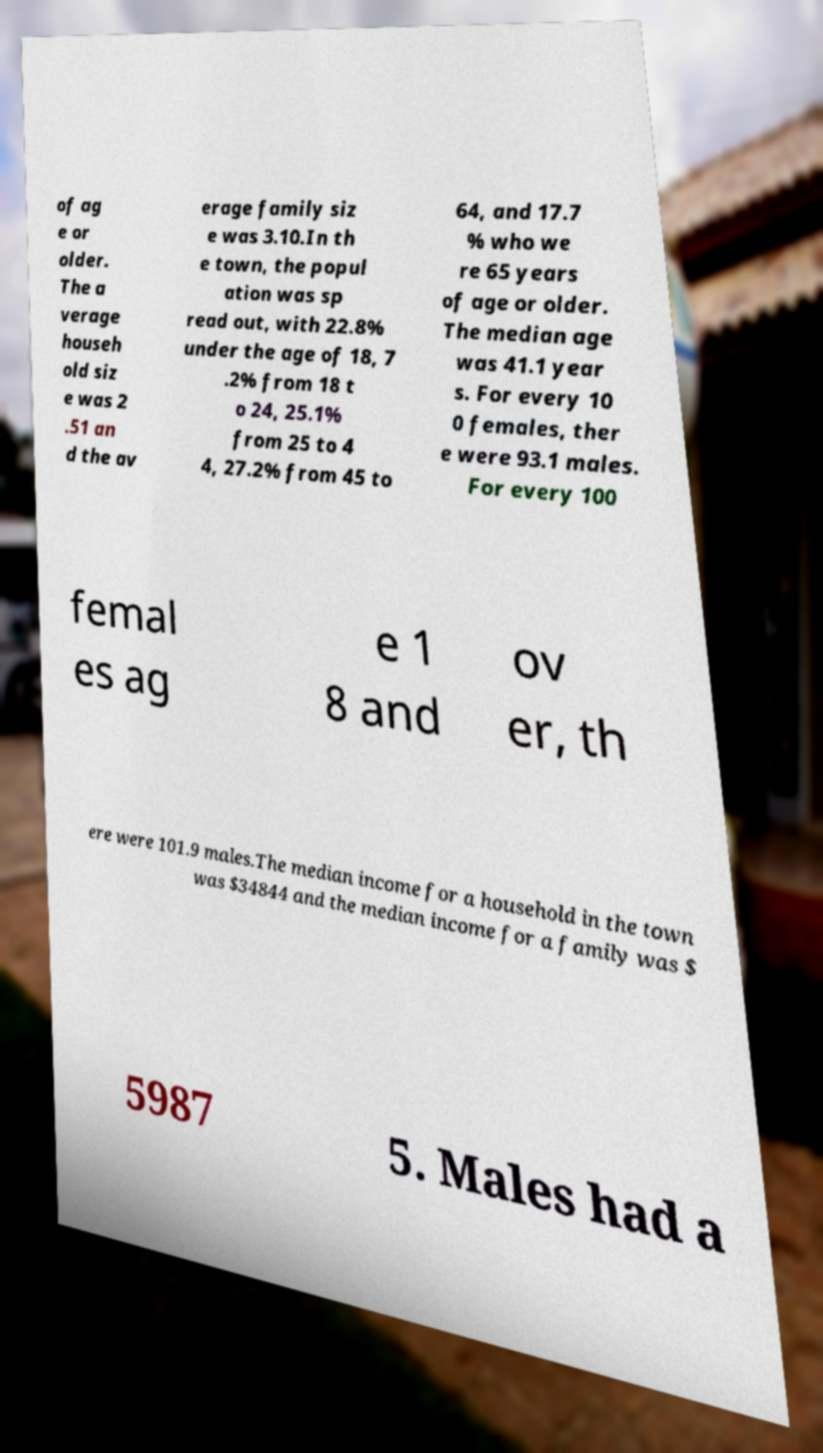Could you assist in decoding the text presented in this image and type it out clearly? of ag e or older. The a verage househ old siz e was 2 .51 an d the av erage family siz e was 3.10.In th e town, the popul ation was sp read out, with 22.8% under the age of 18, 7 .2% from 18 t o 24, 25.1% from 25 to 4 4, 27.2% from 45 to 64, and 17.7 % who we re 65 years of age or older. The median age was 41.1 year s. For every 10 0 females, ther e were 93.1 males. For every 100 femal es ag e 1 8 and ov er, th ere were 101.9 males.The median income for a household in the town was $34844 and the median income for a family was $ 5987 5. Males had a 